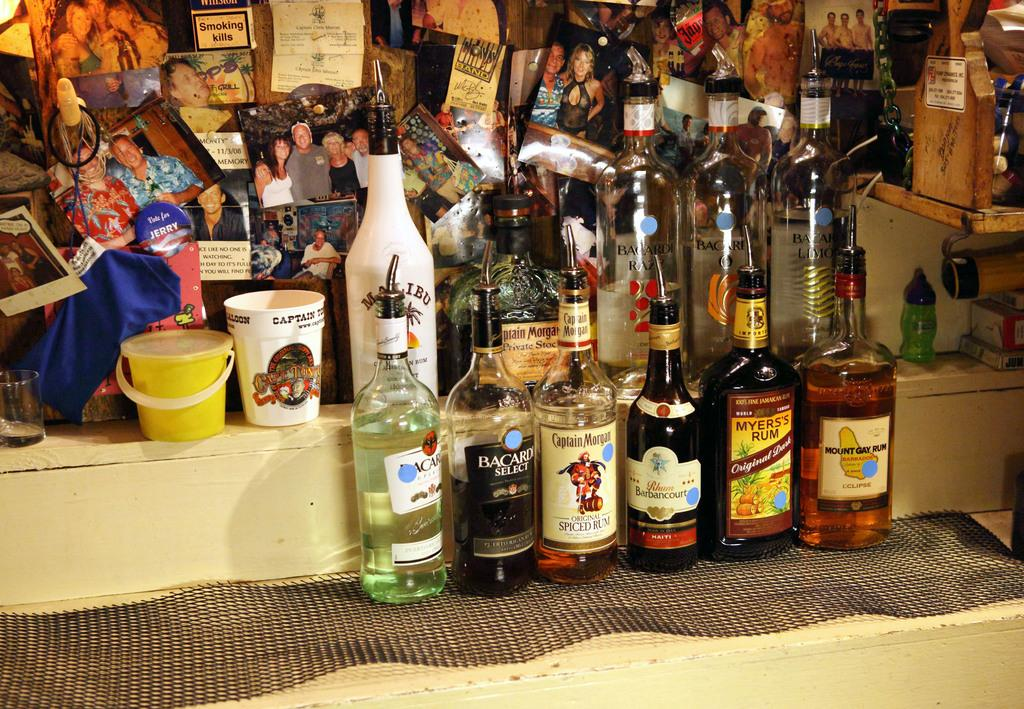<image>
Render a clear and concise summary of the photo. Bottle of Mount Gay Rum and A bottle of Bacardi Select. 